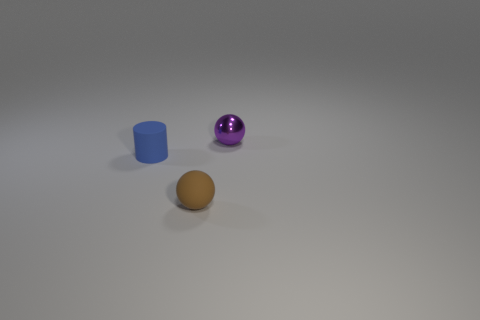Add 3 small purple rubber things. How many objects exist? 6 Add 3 tiny blue objects. How many tiny blue objects exist? 4 Subtract 0 purple cubes. How many objects are left? 3 Subtract all cylinders. How many objects are left? 2 Subtract all brown balls. Subtract all red cylinders. How many balls are left? 1 Subtract all purple objects. Subtract all tiny purple balls. How many objects are left? 1 Add 3 balls. How many balls are left? 5 